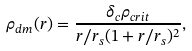<formula> <loc_0><loc_0><loc_500><loc_500>\rho _ { d m } ( r ) = \frac { \delta _ { c } \rho _ { c r i t } } { r / r _ { s } ( 1 + r / r _ { s } ) ^ { 2 } } ,</formula> 